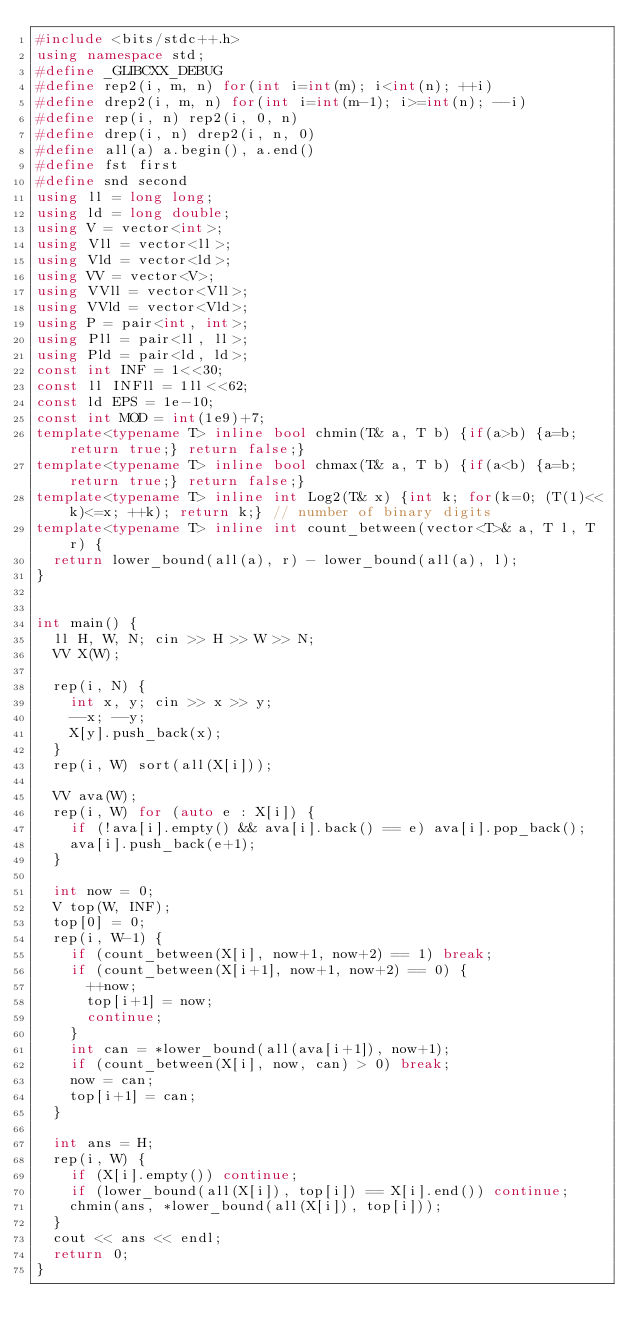Convert code to text. <code><loc_0><loc_0><loc_500><loc_500><_C++_>#include <bits/stdc++.h>
using namespace std;
#define _GLIBCXX_DEBUG
#define rep2(i, m, n) for(int i=int(m); i<int(n); ++i)
#define drep2(i, m, n) for(int i=int(m-1); i>=int(n); --i)
#define rep(i, n) rep2(i, 0, n)
#define drep(i, n) drep2(i, n, 0)
#define all(a) a.begin(), a.end()
#define fst first
#define snd second
using ll = long long;
using ld = long double;
using V = vector<int>;
using Vll = vector<ll>;
using Vld = vector<ld>;
using VV = vector<V>;
using VVll = vector<Vll>;
using VVld = vector<Vld>;
using P = pair<int, int>;
using Pll = pair<ll, ll>;
using Pld = pair<ld, ld>;
const int INF = 1<<30;
const ll INFll = 1ll<<62;
const ld EPS = 1e-10;
const int MOD = int(1e9)+7;
template<typename T> inline bool chmin(T& a, T b) {if(a>b) {a=b; return true;} return false;}
template<typename T> inline bool chmax(T& a, T b) {if(a<b) {a=b; return true;} return false;}
template<typename T> inline int Log2(T& x) {int k; for(k=0; (T(1)<<k)<=x; ++k); return k;} // number of binary digits
template<typename T> inline int count_between(vector<T>& a, T l, T r) {
  return lower_bound(all(a), r) - lower_bound(all(a), l);
}


int main() {
  ll H, W, N; cin >> H >> W >> N;
  VV X(W);

  rep(i, N) {
    int x, y; cin >> x >> y;
    --x; --y;
    X[y].push_back(x);
  }
  rep(i, W) sort(all(X[i]));

  VV ava(W);
  rep(i, W) for (auto e : X[i]) {
    if (!ava[i].empty() && ava[i].back() == e) ava[i].pop_back();
    ava[i].push_back(e+1);
  }

  int now = 0;
  V top(W, INF);
  top[0] = 0;
  rep(i, W-1) {
    if (count_between(X[i], now+1, now+2) == 1) break;
    if (count_between(X[i+1], now+1, now+2) == 0) {
      ++now;
      top[i+1] = now;
      continue;
    }
    int can = *lower_bound(all(ava[i+1]), now+1);
    if (count_between(X[i], now, can) > 0) break;
    now = can;
    top[i+1] = can;
  }

  int ans = H;
  rep(i, W) {
    if (X[i].empty()) continue;
    if (lower_bound(all(X[i]), top[i]) == X[i].end()) continue;
    chmin(ans, *lower_bound(all(X[i]), top[i]));
  }
  cout << ans << endl;
  return 0;
}
</code> 